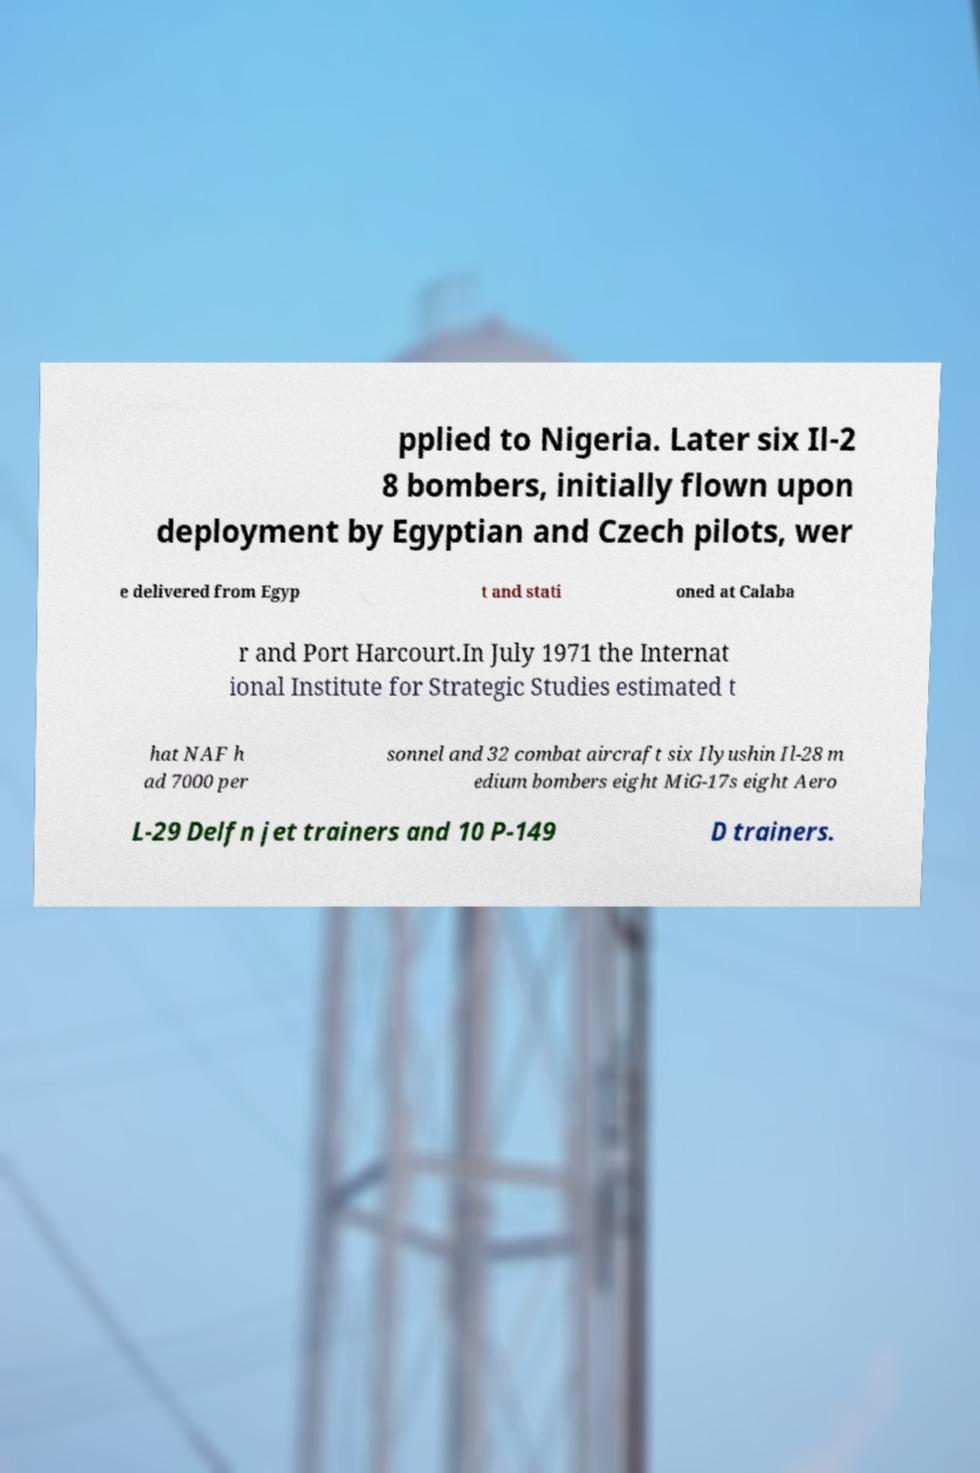I need the written content from this picture converted into text. Can you do that? pplied to Nigeria. Later six Il-2 8 bombers, initially flown upon deployment by Egyptian and Czech pilots, wer e delivered from Egyp t and stati oned at Calaba r and Port Harcourt.In July 1971 the Internat ional Institute for Strategic Studies estimated t hat NAF h ad 7000 per sonnel and 32 combat aircraft six Ilyushin Il-28 m edium bombers eight MiG-17s eight Aero L-29 Delfn jet trainers and 10 P-149 D trainers. 